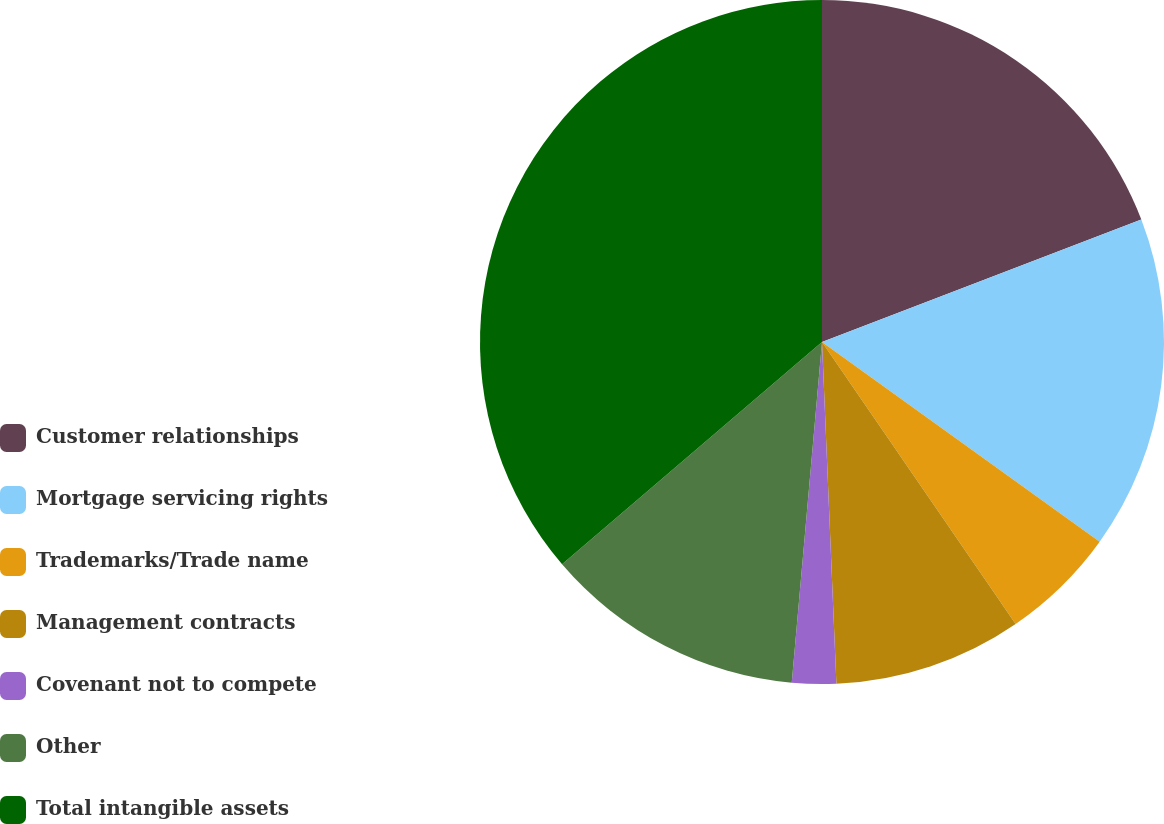<chart> <loc_0><loc_0><loc_500><loc_500><pie_chart><fcel>Customer relationships<fcel>Mortgage servicing rights<fcel>Trademarks/Trade name<fcel>Management contracts<fcel>Covenant not to compete<fcel>Other<fcel>Total intangible assets<nl><fcel>19.17%<fcel>15.75%<fcel>5.5%<fcel>8.91%<fcel>2.08%<fcel>12.33%<fcel>36.26%<nl></chart> 